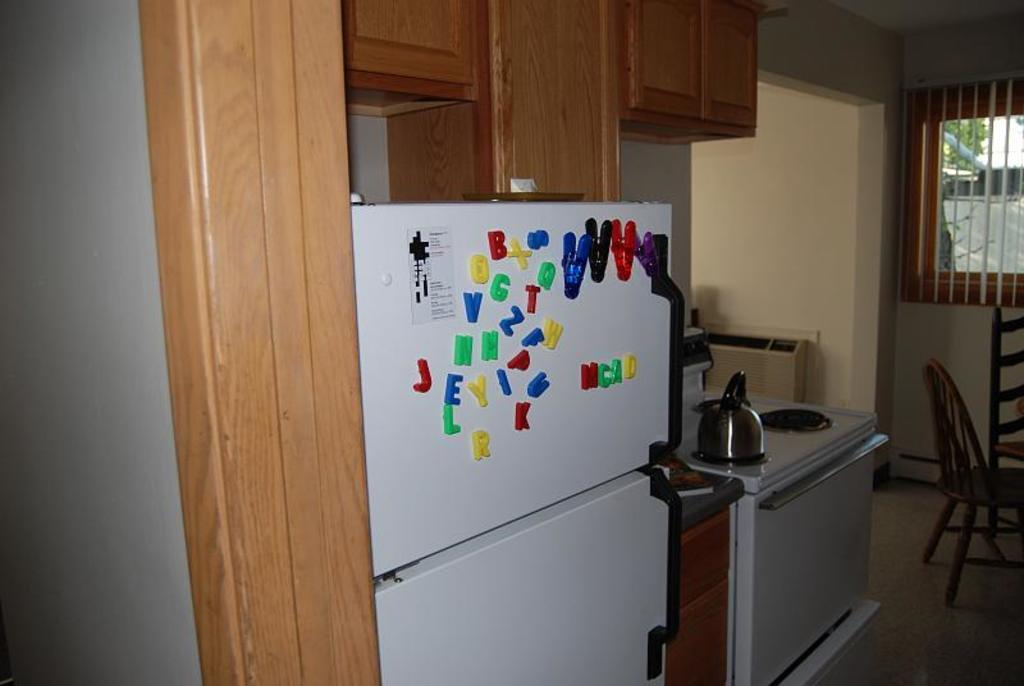<image>
Create a compact narrative representing the image presented. A refrigerator with alphabetical magnets on display in a standard kitchen. 